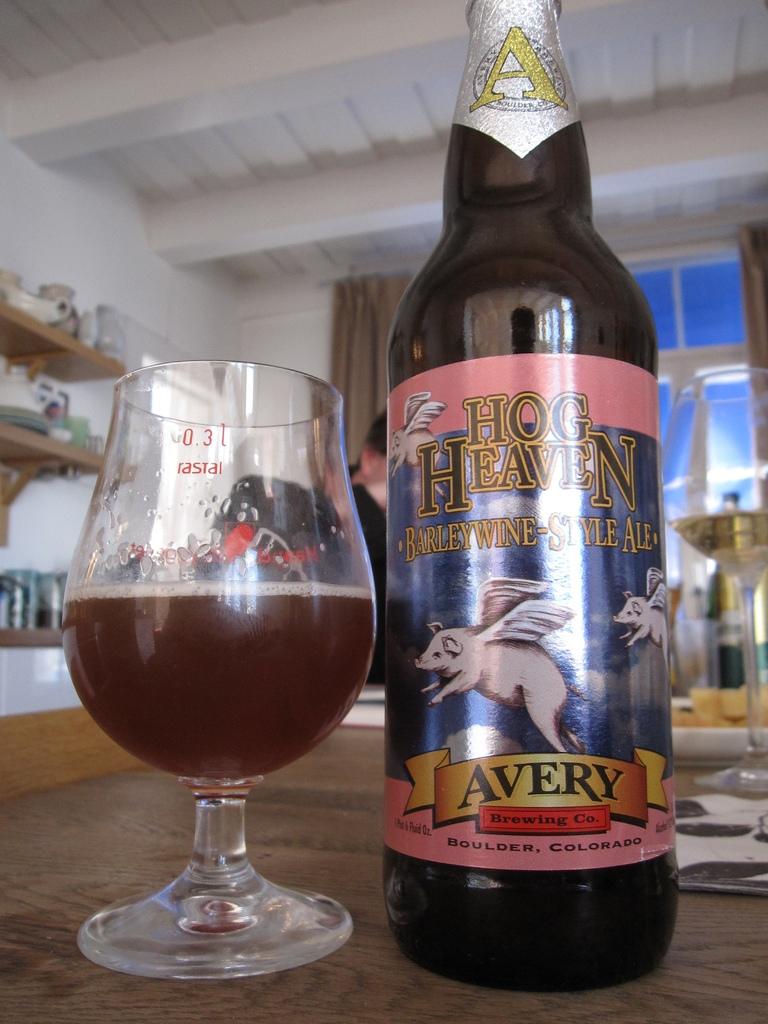Who is the brewery of this beverage?
Your answer should be compact. Avery. 